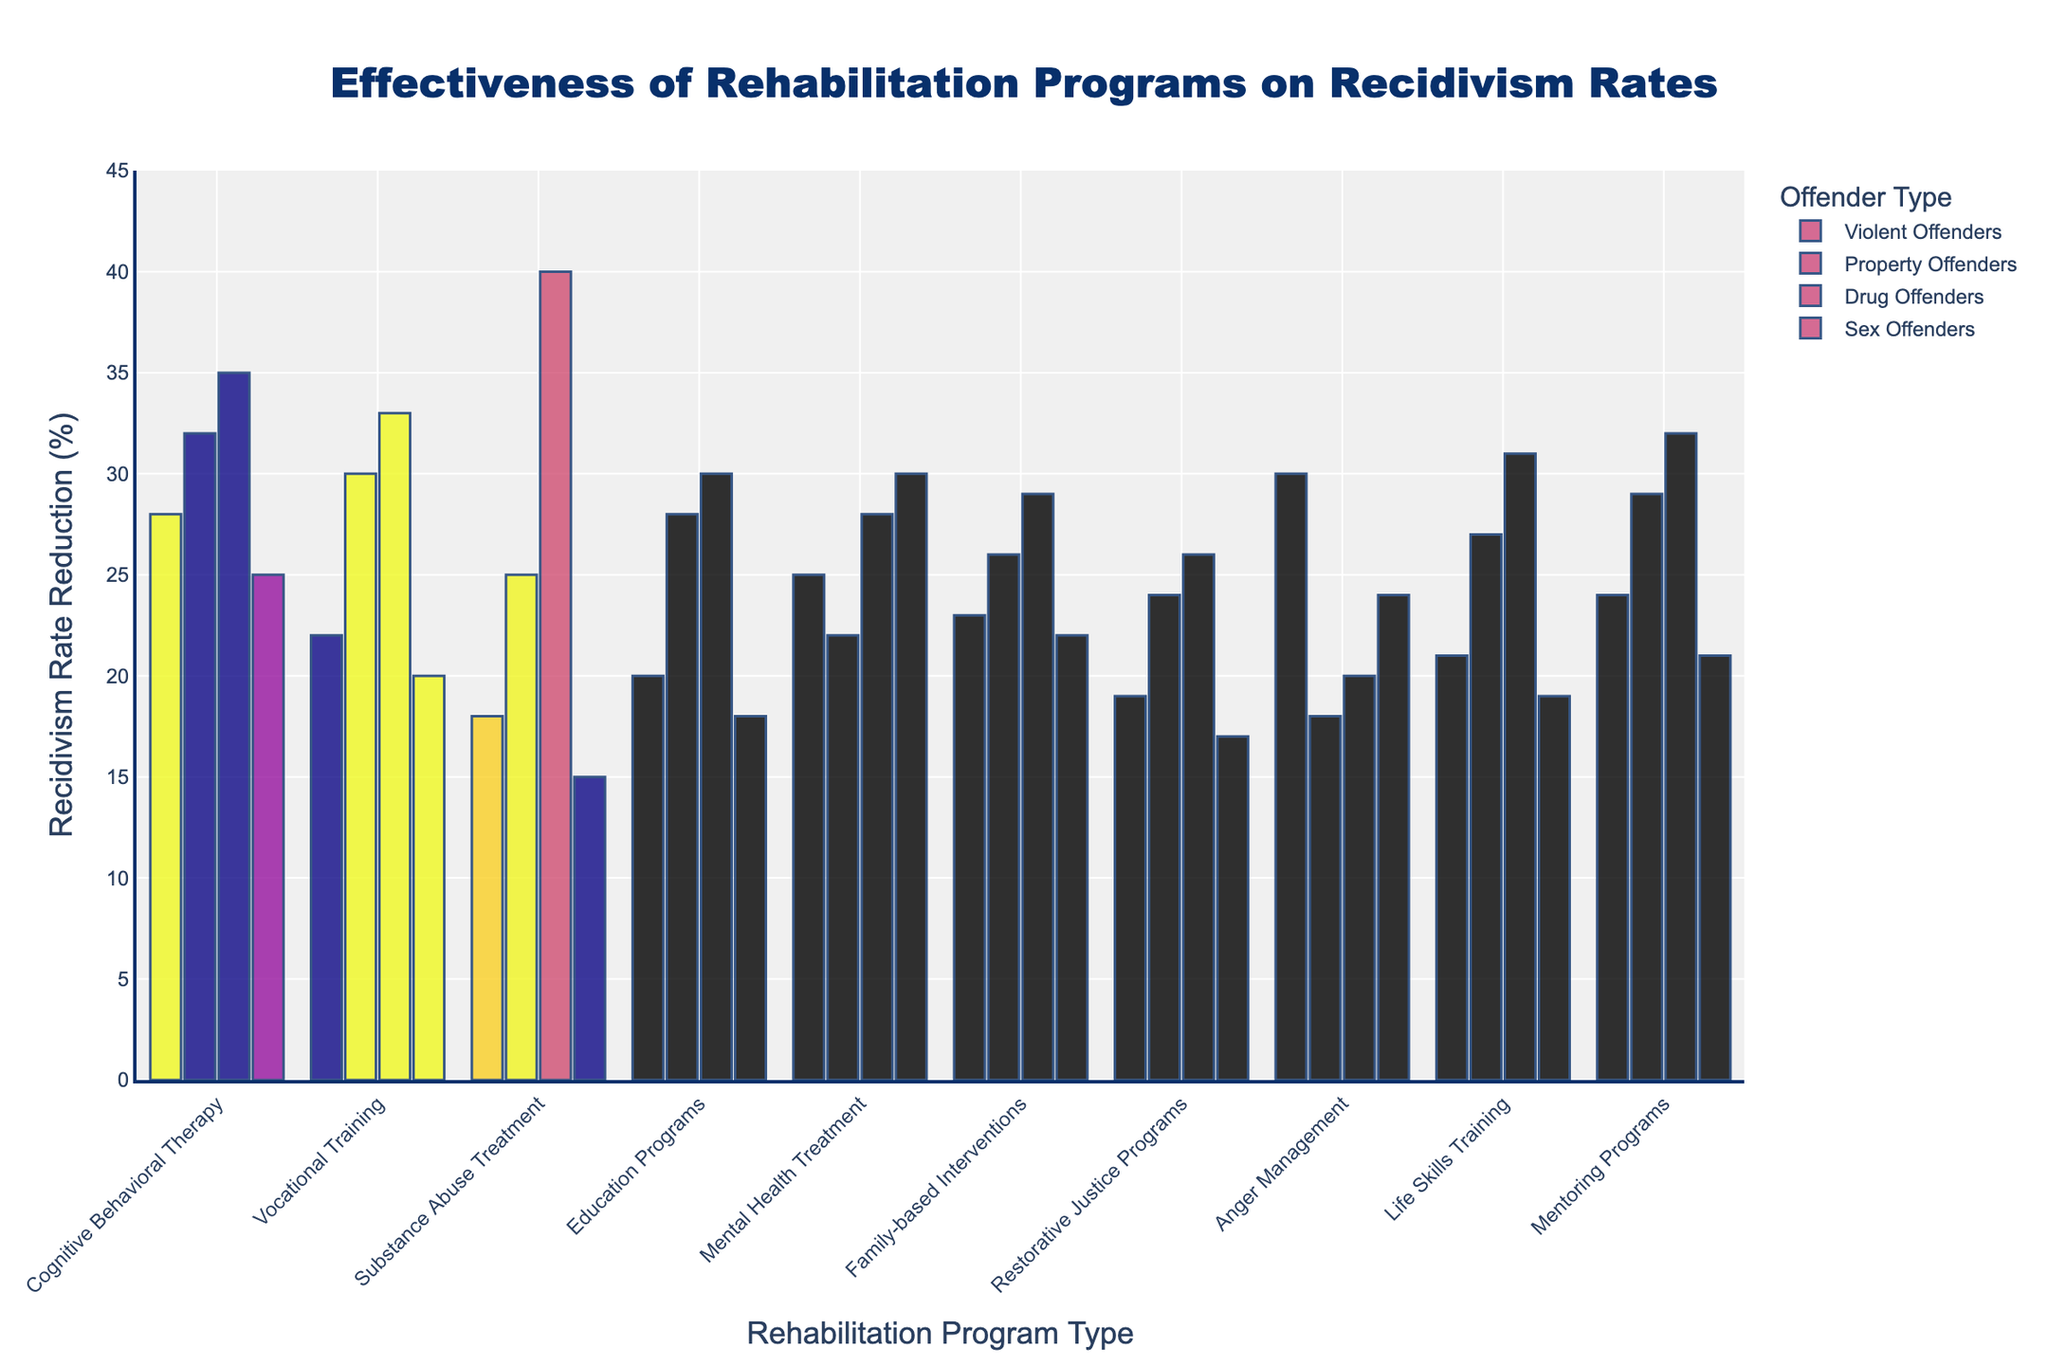what is the most effective rehabilitation program for reducing recidivism rates among drug offenders? To determine the most effective rehabilitation program for drug offenders, look for the highest bar within the "Drug Offenders" group. The highest value here corresponds to the "Substance Abuse Treatment" program at 40%.
Answer: Substance Abuse Treatment which offender type shows the highest reduction in recidivism rates from cognitive behavioral therapy? To find this, examine the bars corresponding to "Cognitive Behavioral Therapy" and identify the offender type with the tallest bar. The "Drug Offenders" category has the highest reduction at 35%.
Answer: Drug Offenders Among violent offenders, which rehabilitation program shows the least recidivism rate reduction? For violent offenders, check for the shortest bar. The rehabilitation program with the least recidivism rate reduction for violent offenders is "Substance Abuse Treatment" at 18%.
Answer: Substance Abuse Treatment What is the difference in recidivism rate reduction between vocational training and anger management for property offenders? For property offenders, find the bars for "Vocational Training" and "Anger Management." "Vocational Training" shows a reduction of 30%, and "Anger Management" shows 18%. Thus, the difference is 30% - 18% = 12%.
Answer: 12% Which program is equally effective for both violent and sex offenders? Look for programs where the bars for "Violent Offenders" and "Sex Offenders" are of equal height. "Mental Health Treatment" has both at 30%.
Answer: Mental Health Treatment What is the average recidivism rate reduction for education programs across all offender types? Calculate the mean by summing the rates for education programs (20% for violent, 28% for property, 30% for drug, and 18% for sex offenders) and dividing by the number of categories: (20 + 28 + 30 + 18) / 4 = 24%.
Answer: 24% Which offender type sees a higher reduction in recidivism rates from family-based interventions compared to mental health treatment? Compare the bars of "Family-based Interventions" and "Mental Health Treatment" for each offender type. Family-based interventions have higher rates in "Violent Offenders" (23% vs. 25%) and "Property Offenders" (26% vs. 22%) only.
Answer: Property Offenders What's the difference between the highest and lowest recidivism rate reductions for drug offenders among all programs? For drug offenders, identify the highest (40% for "Substance Abuse Treatment") and the lowest (20% for "Anger Management") values. The difference is 40% - 20% = 20%.
Answer: 20% In which offender type does restorative justice programs show greater effectiveness (higher recidivism rate reduction) compared to mental health treatment? Compare bars for "Restorative Justice Programs" and "Mental Health Treatment" for each type. "Restorative Justice Programs" is only more effective for property offenders (24% vs. 22%).
Answer: Property Offenders Which set of programs shows a consistent decrease in recidivism rates moving from property offenders to sex offenders? Analyze the bars for each program across the four offender types and check which set of programs does not increase from "Property Offenders" to "Sex Offenders." No single program shows a consistent decrease for all types.
Answer: None 